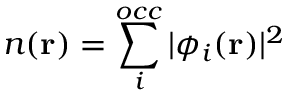Convert formula to latex. <formula><loc_0><loc_0><loc_500><loc_500>n ( r ) = \sum _ { i } ^ { o c c } | \phi _ { i } ( { r } ) | ^ { 2 }</formula> 